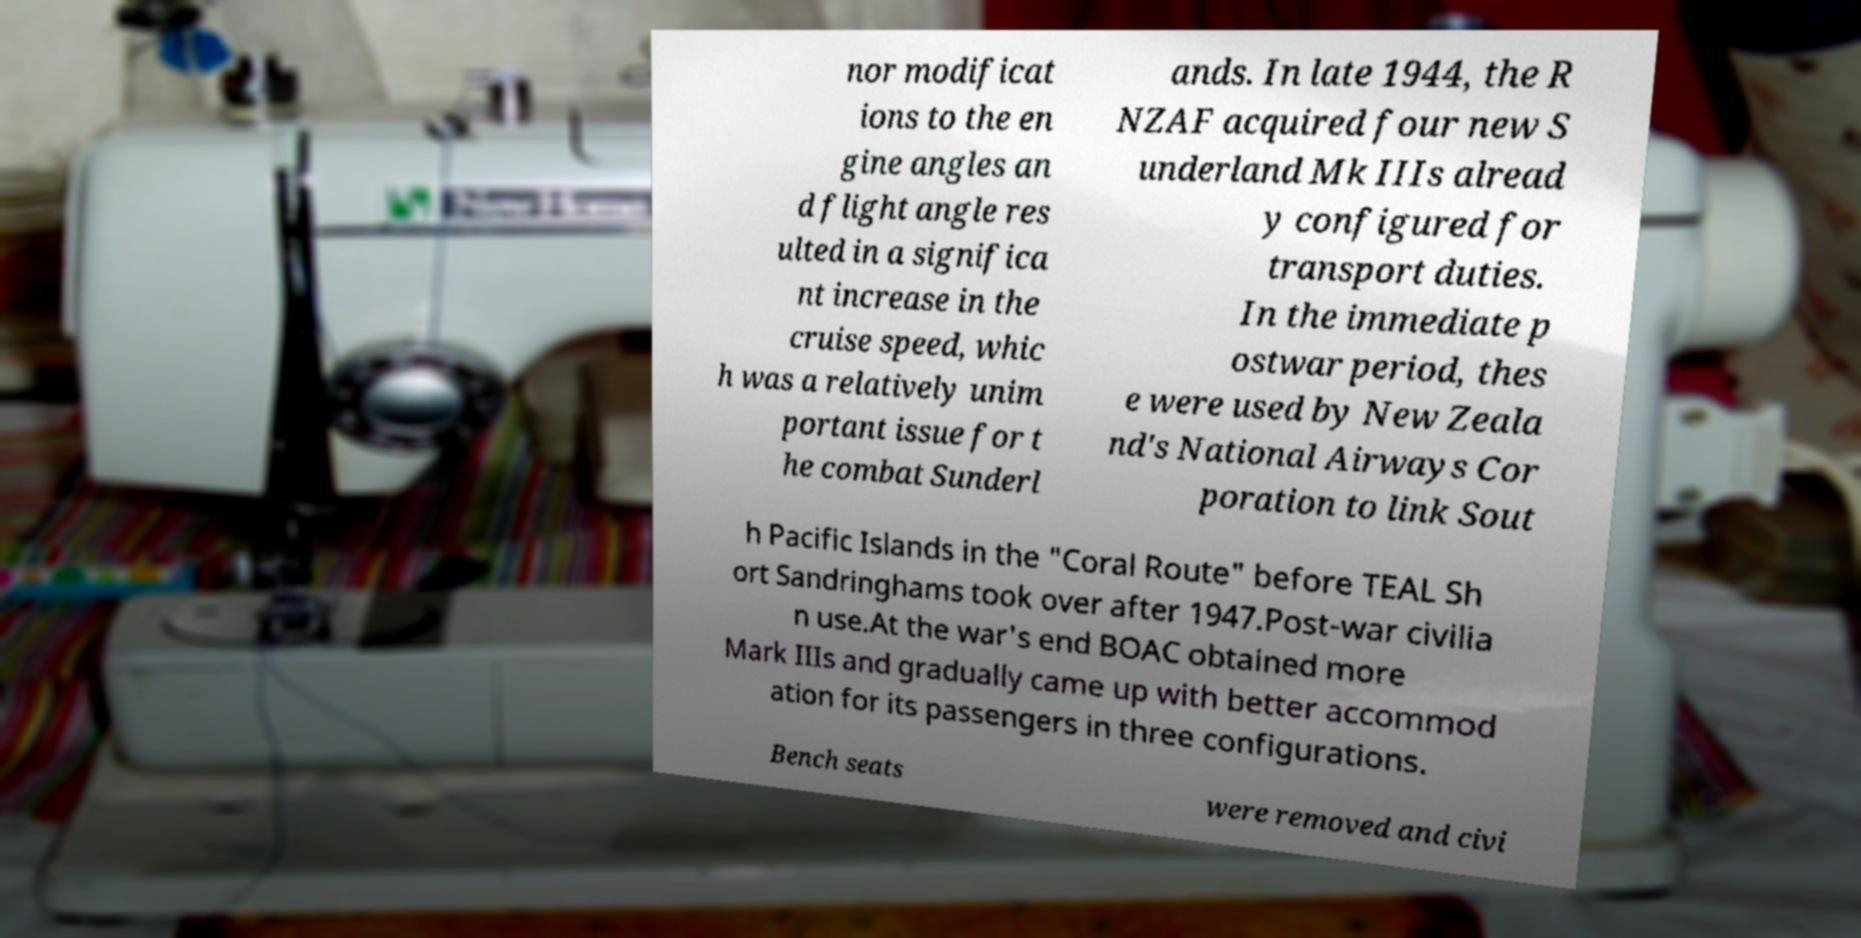I need the written content from this picture converted into text. Can you do that? nor modificat ions to the en gine angles an d flight angle res ulted in a significa nt increase in the cruise speed, whic h was a relatively unim portant issue for t he combat Sunderl ands. In late 1944, the R NZAF acquired four new S underland Mk IIIs alread y configured for transport duties. In the immediate p ostwar period, thes e were used by New Zeala nd's National Airways Cor poration to link Sout h Pacific Islands in the "Coral Route" before TEAL Sh ort Sandringhams took over after 1947.Post-war civilia n use.At the war's end BOAC obtained more Mark IIIs and gradually came up with better accommod ation for its passengers in three configurations. Bench seats were removed and civi 